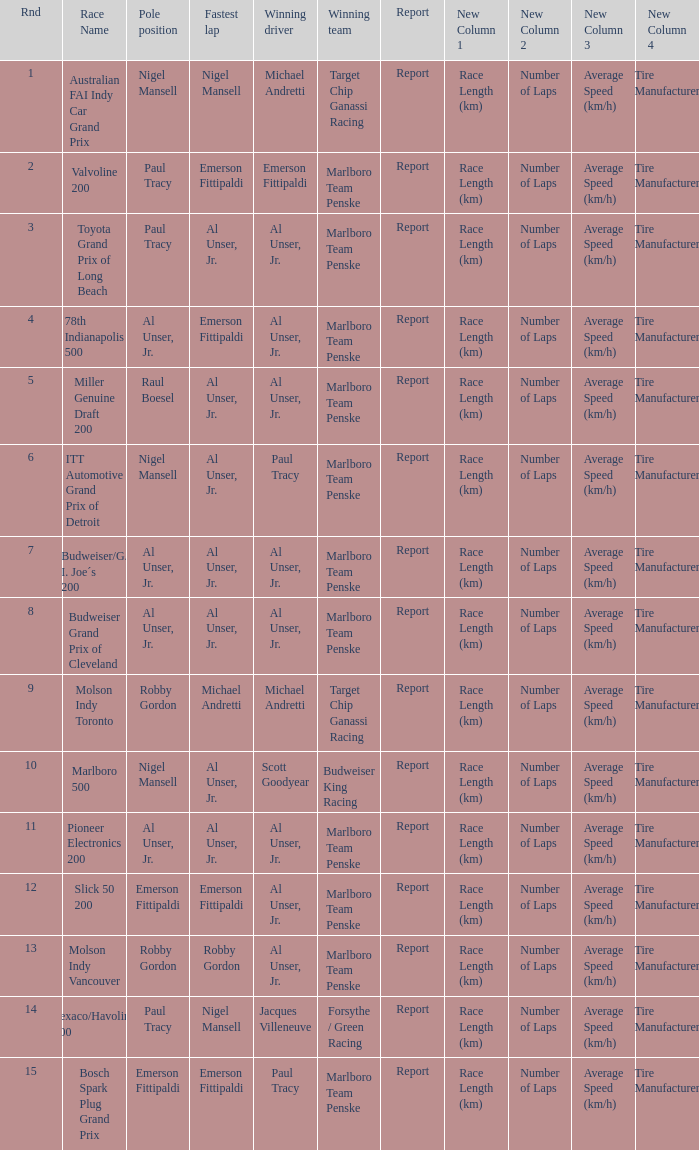What's the report of the race won by Michael Andretti, with Nigel Mansell driving the fastest lap? Report. 